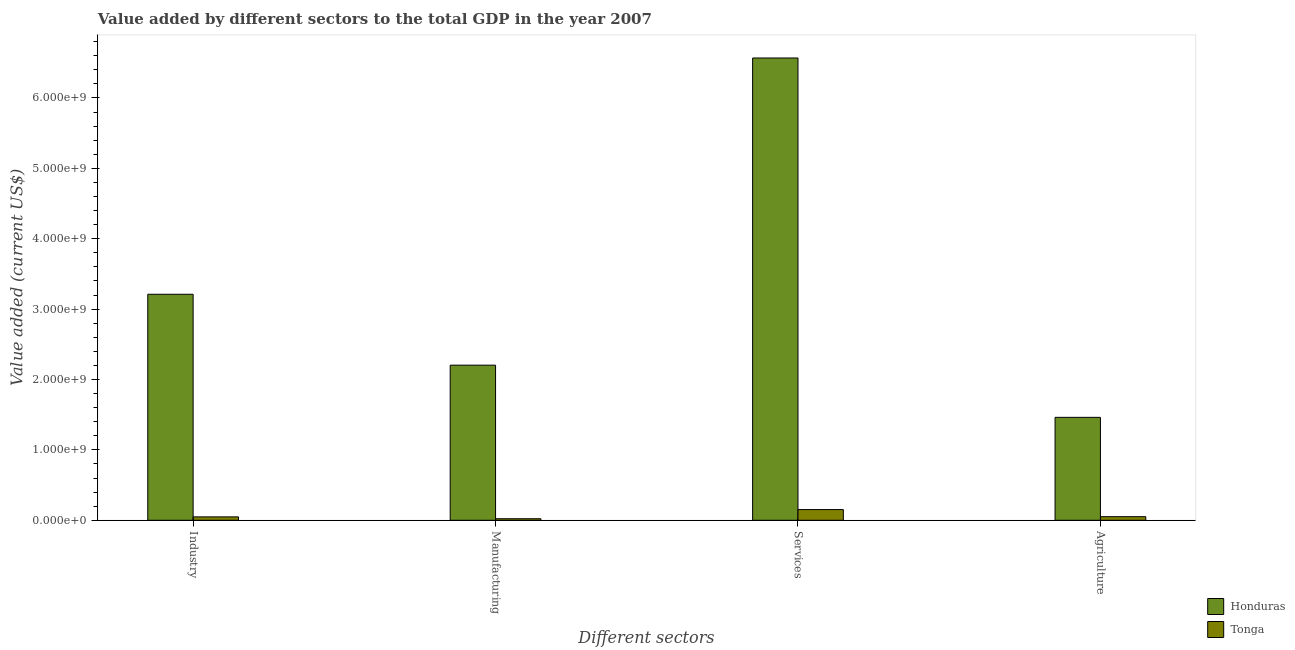How many different coloured bars are there?
Offer a terse response. 2. How many groups of bars are there?
Your answer should be compact. 4. Are the number of bars per tick equal to the number of legend labels?
Provide a succinct answer. Yes. What is the label of the 1st group of bars from the left?
Make the answer very short. Industry. What is the value added by industrial sector in Tonga?
Give a very brief answer. 4.81e+07. Across all countries, what is the maximum value added by agricultural sector?
Your response must be concise. 1.46e+09. Across all countries, what is the minimum value added by manufacturing sector?
Provide a short and direct response. 2.17e+07. In which country was the value added by industrial sector maximum?
Make the answer very short. Honduras. In which country was the value added by agricultural sector minimum?
Give a very brief answer. Tonga. What is the total value added by manufacturing sector in the graph?
Your answer should be very brief. 2.23e+09. What is the difference between the value added by services sector in Tonga and that in Honduras?
Provide a short and direct response. -6.42e+09. What is the difference between the value added by manufacturing sector in Honduras and the value added by services sector in Tonga?
Keep it short and to the point. 2.05e+09. What is the average value added by agricultural sector per country?
Your answer should be very brief. 7.57e+08. What is the difference between the value added by manufacturing sector and value added by agricultural sector in Honduras?
Your response must be concise. 7.41e+08. In how many countries, is the value added by agricultural sector greater than 1600000000 US$?
Ensure brevity in your answer.  0. What is the ratio of the value added by services sector in Tonga to that in Honduras?
Give a very brief answer. 0.02. Is the difference between the value added by manufacturing sector in Tonga and Honduras greater than the difference between the value added by agricultural sector in Tonga and Honduras?
Make the answer very short. No. What is the difference between the highest and the second highest value added by manufacturing sector?
Keep it short and to the point. 2.18e+09. What is the difference between the highest and the lowest value added by services sector?
Provide a short and direct response. 6.42e+09. Is the sum of the value added by agricultural sector in Honduras and Tonga greater than the maximum value added by manufacturing sector across all countries?
Provide a succinct answer. No. What does the 1st bar from the left in Industry represents?
Your answer should be very brief. Honduras. What does the 1st bar from the right in Services represents?
Make the answer very short. Tonga. Is it the case that in every country, the sum of the value added by industrial sector and value added by manufacturing sector is greater than the value added by services sector?
Offer a terse response. No. Are all the bars in the graph horizontal?
Provide a succinct answer. No. How many countries are there in the graph?
Provide a succinct answer. 2. Are the values on the major ticks of Y-axis written in scientific E-notation?
Your response must be concise. Yes. Does the graph contain grids?
Offer a terse response. No. How many legend labels are there?
Provide a short and direct response. 2. How are the legend labels stacked?
Ensure brevity in your answer.  Vertical. What is the title of the graph?
Ensure brevity in your answer.  Value added by different sectors to the total GDP in the year 2007. What is the label or title of the X-axis?
Offer a terse response. Different sectors. What is the label or title of the Y-axis?
Provide a short and direct response. Value added (current US$). What is the Value added (current US$) of Honduras in Industry?
Make the answer very short. 3.21e+09. What is the Value added (current US$) in Tonga in Industry?
Provide a short and direct response. 4.81e+07. What is the Value added (current US$) in Honduras in Manufacturing?
Make the answer very short. 2.20e+09. What is the Value added (current US$) of Tonga in Manufacturing?
Provide a short and direct response. 2.17e+07. What is the Value added (current US$) in Honduras in Services?
Offer a terse response. 6.57e+09. What is the Value added (current US$) in Tonga in Services?
Your answer should be very brief. 1.52e+08. What is the Value added (current US$) in Honduras in Agriculture?
Give a very brief answer. 1.46e+09. What is the Value added (current US$) in Tonga in Agriculture?
Make the answer very short. 5.10e+07. Across all Different sectors, what is the maximum Value added (current US$) of Honduras?
Give a very brief answer. 6.57e+09. Across all Different sectors, what is the maximum Value added (current US$) of Tonga?
Make the answer very short. 1.52e+08. Across all Different sectors, what is the minimum Value added (current US$) of Honduras?
Give a very brief answer. 1.46e+09. Across all Different sectors, what is the minimum Value added (current US$) of Tonga?
Provide a succinct answer. 2.17e+07. What is the total Value added (current US$) of Honduras in the graph?
Give a very brief answer. 1.34e+1. What is the total Value added (current US$) of Tonga in the graph?
Give a very brief answer. 2.73e+08. What is the difference between the Value added (current US$) in Honduras in Industry and that in Manufacturing?
Give a very brief answer. 1.01e+09. What is the difference between the Value added (current US$) in Tonga in Industry and that in Manufacturing?
Your answer should be compact. 2.64e+07. What is the difference between the Value added (current US$) in Honduras in Industry and that in Services?
Make the answer very short. -3.36e+09. What is the difference between the Value added (current US$) in Tonga in Industry and that in Services?
Keep it short and to the point. -1.04e+08. What is the difference between the Value added (current US$) in Honduras in Industry and that in Agriculture?
Ensure brevity in your answer.  1.75e+09. What is the difference between the Value added (current US$) of Tonga in Industry and that in Agriculture?
Give a very brief answer. -2.83e+06. What is the difference between the Value added (current US$) in Honduras in Manufacturing and that in Services?
Provide a short and direct response. -4.36e+09. What is the difference between the Value added (current US$) of Tonga in Manufacturing and that in Services?
Your answer should be very brief. -1.30e+08. What is the difference between the Value added (current US$) of Honduras in Manufacturing and that in Agriculture?
Your answer should be very brief. 7.41e+08. What is the difference between the Value added (current US$) in Tonga in Manufacturing and that in Agriculture?
Offer a very short reply. -2.92e+07. What is the difference between the Value added (current US$) in Honduras in Services and that in Agriculture?
Your answer should be compact. 5.11e+09. What is the difference between the Value added (current US$) in Tonga in Services and that in Agriculture?
Offer a very short reply. 1.01e+08. What is the difference between the Value added (current US$) of Honduras in Industry and the Value added (current US$) of Tonga in Manufacturing?
Make the answer very short. 3.19e+09. What is the difference between the Value added (current US$) of Honduras in Industry and the Value added (current US$) of Tonga in Services?
Your answer should be very brief. 3.06e+09. What is the difference between the Value added (current US$) of Honduras in Industry and the Value added (current US$) of Tonga in Agriculture?
Give a very brief answer. 3.16e+09. What is the difference between the Value added (current US$) of Honduras in Manufacturing and the Value added (current US$) of Tonga in Services?
Make the answer very short. 2.05e+09. What is the difference between the Value added (current US$) of Honduras in Manufacturing and the Value added (current US$) of Tonga in Agriculture?
Your answer should be very brief. 2.15e+09. What is the difference between the Value added (current US$) in Honduras in Services and the Value added (current US$) in Tonga in Agriculture?
Your answer should be compact. 6.52e+09. What is the average Value added (current US$) in Honduras per Different sectors?
Provide a short and direct response. 3.36e+09. What is the average Value added (current US$) in Tonga per Different sectors?
Your response must be concise. 6.82e+07. What is the difference between the Value added (current US$) in Honduras and Value added (current US$) in Tonga in Industry?
Provide a succinct answer. 3.16e+09. What is the difference between the Value added (current US$) of Honduras and Value added (current US$) of Tonga in Manufacturing?
Your response must be concise. 2.18e+09. What is the difference between the Value added (current US$) of Honduras and Value added (current US$) of Tonga in Services?
Offer a terse response. 6.42e+09. What is the difference between the Value added (current US$) of Honduras and Value added (current US$) of Tonga in Agriculture?
Your answer should be compact. 1.41e+09. What is the ratio of the Value added (current US$) in Honduras in Industry to that in Manufacturing?
Ensure brevity in your answer.  1.46. What is the ratio of the Value added (current US$) in Tonga in Industry to that in Manufacturing?
Offer a terse response. 2.21. What is the ratio of the Value added (current US$) in Honduras in Industry to that in Services?
Your answer should be compact. 0.49. What is the ratio of the Value added (current US$) in Tonga in Industry to that in Services?
Offer a very short reply. 0.32. What is the ratio of the Value added (current US$) of Honduras in Industry to that in Agriculture?
Keep it short and to the point. 2.2. What is the ratio of the Value added (current US$) in Tonga in Industry to that in Agriculture?
Make the answer very short. 0.94. What is the ratio of the Value added (current US$) in Honduras in Manufacturing to that in Services?
Your response must be concise. 0.34. What is the ratio of the Value added (current US$) of Tonga in Manufacturing to that in Services?
Provide a short and direct response. 0.14. What is the ratio of the Value added (current US$) of Honduras in Manufacturing to that in Agriculture?
Your answer should be very brief. 1.51. What is the ratio of the Value added (current US$) in Tonga in Manufacturing to that in Agriculture?
Your answer should be compact. 0.43. What is the ratio of the Value added (current US$) in Honduras in Services to that in Agriculture?
Your answer should be very brief. 4.49. What is the ratio of the Value added (current US$) in Tonga in Services to that in Agriculture?
Keep it short and to the point. 2.98. What is the difference between the highest and the second highest Value added (current US$) in Honduras?
Your answer should be very brief. 3.36e+09. What is the difference between the highest and the second highest Value added (current US$) in Tonga?
Your response must be concise. 1.01e+08. What is the difference between the highest and the lowest Value added (current US$) in Honduras?
Offer a very short reply. 5.11e+09. What is the difference between the highest and the lowest Value added (current US$) in Tonga?
Offer a very short reply. 1.30e+08. 